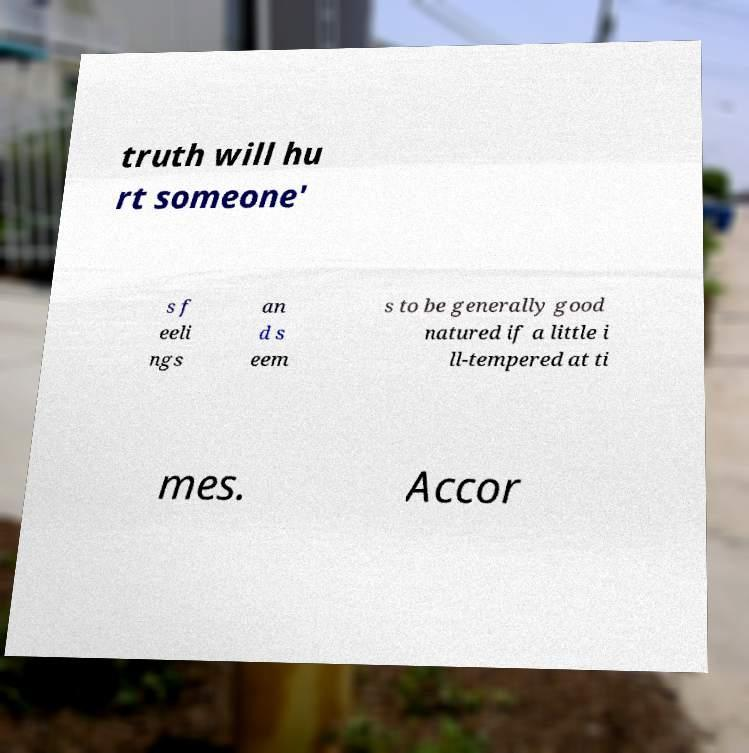For documentation purposes, I need the text within this image transcribed. Could you provide that? truth will hu rt someone' s f eeli ngs an d s eem s to be generally good natured if a little i ll-tempered at ti mes. Accor 